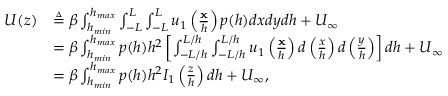Convert formula to latex. <formula><loc_0><loc_0><loc_500><loc_500>\begin{array} { r l } { U ( z ) } & { \triangle q \beta \int _ { h _ { \min } } ^ { h _ { \max } } \int _ { - L } ^ { L } \int _ { - L } ^ { L } u _ { 1 } \left ( \frac { x } { h } \right ) p ( h ) d x d y d h + U _ { \infty } } \\ & { = \beta \int _ { h _ { \min } } ^ { h _ { \max } } p ( h ) h ^ { 2 } \left [ \int _ { - L / h } ^ { L / h } \int _ { - L / h } ^ { L / h } u _ { 1 } \left ( \frac { x } { h } \right ) d \left ( \frac { x } { h } \right ) d \left ( \frac { y } { h } \right ) \right ] d h + U _ { \infty } } \\ & { = \beta \int _ { h _ { \min } } ^ { h _ { \max } } p ( h ) h ^ { 2 } I _ { 1 } \left ( \frac { z } { h } \right ) d h + U _ { \infty } , } \end{array}</formula> 